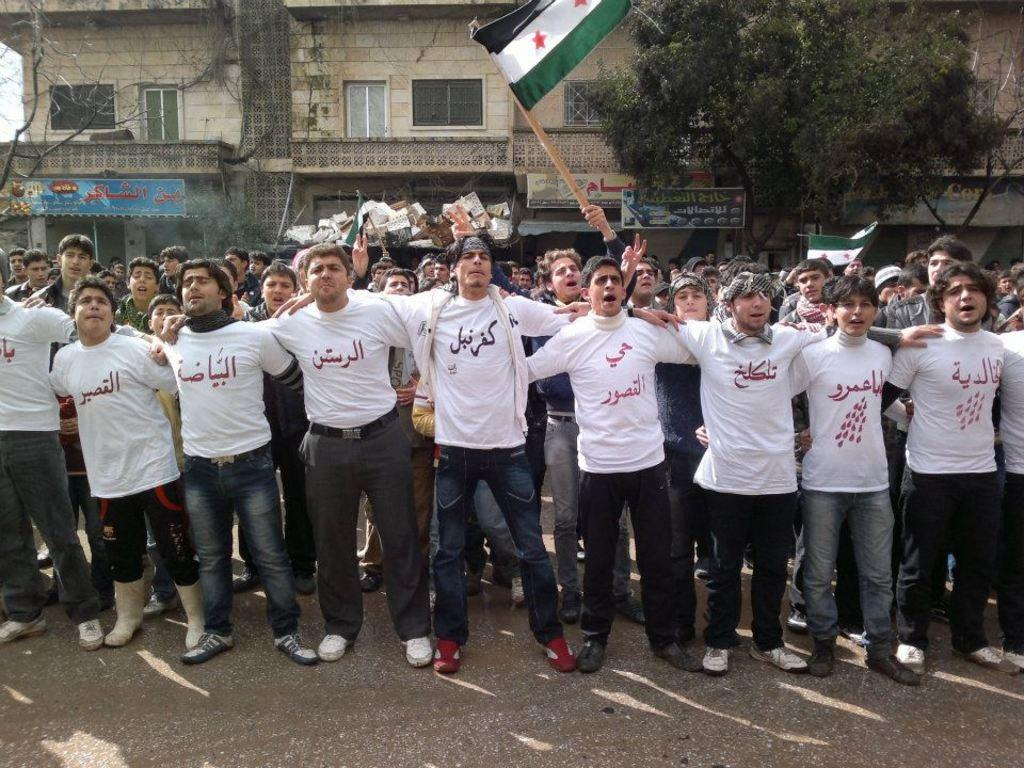What is happening with the group of people in the image? The people in the image are standing and shouting. What are the people wearing in the image? The people are wearing white color t-shirts. What can be seen in the background of the image? There is a building in the background of the image. What type of vegetation is on the right side of the image? There are trees on the right side of the image. What type of cannon is being used by the people in the image? There is no cannon present in the image; the people are standing and shouting. What books are the people reading in the image? There are no books visible in the image; the people are wearing white t-shirts and standing. 